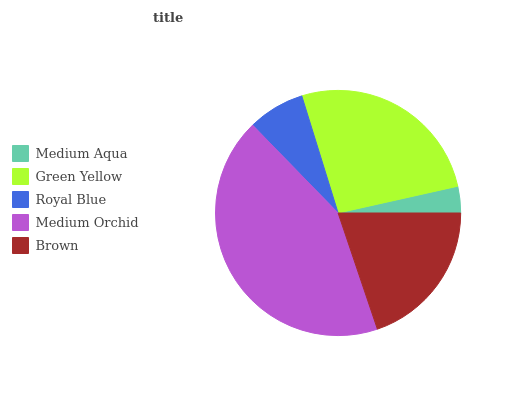Is Medium Aqua the minimum?
Answer yes or no. Yes. Is Medium Orchid the maximum?
Answer yes or no. Yes. Is Green Yellow the minimum?
Answer yes or no. No. Is Green Yellow the maximum?
Answer yes or no. No. Is Green Yellow greater than Medium Aqua?
Answer yes or no. Yes. Is Medium Aqua less than Green Yellow?
Answer yes or no. Yes. Is Medium Aqua greater than Green Yellow?
Answer yes or no. No. Is Green Yellow less than Medium Aqua?
Answer yes or no. No. Is Brown the high median?
Answer yes or no. Yes. Is Brown the low median?
Answer yes or no. Yes. Is Medium Aqua the high median?
Answer yes or no. No. Is Medium Orchid the low median?
Answer yes or no. No. 